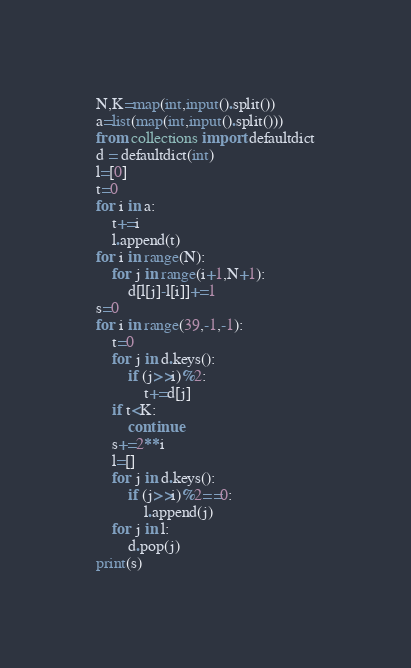Convert code to text. <code><loc_0><loc_0><loc_500><loc_500><_Python_>N,K=map(int,input().split())
a=list(map(int,input().split()))
from collections import defaultdict
d = defaultdict(int)
l=[0]
t=0
for i in a:
    t+=i
    l.append(t)
for i in range(N):
    for j in range(i+1,N+1):
        d[l[j]-l[i]]+=1
s=0
for i in range(39,-1,-1):
    t=0
    for j in d.keys():
        if (j>>i)%2:
            t+=d[j]
    if t<K:
        continue
    s+=2**i
    l=[]
    for j in d.keys():
        if (j>>i)%2==0:
            l.append(j)
    for j in l:
        d.pop(j)
print(s)</code> 